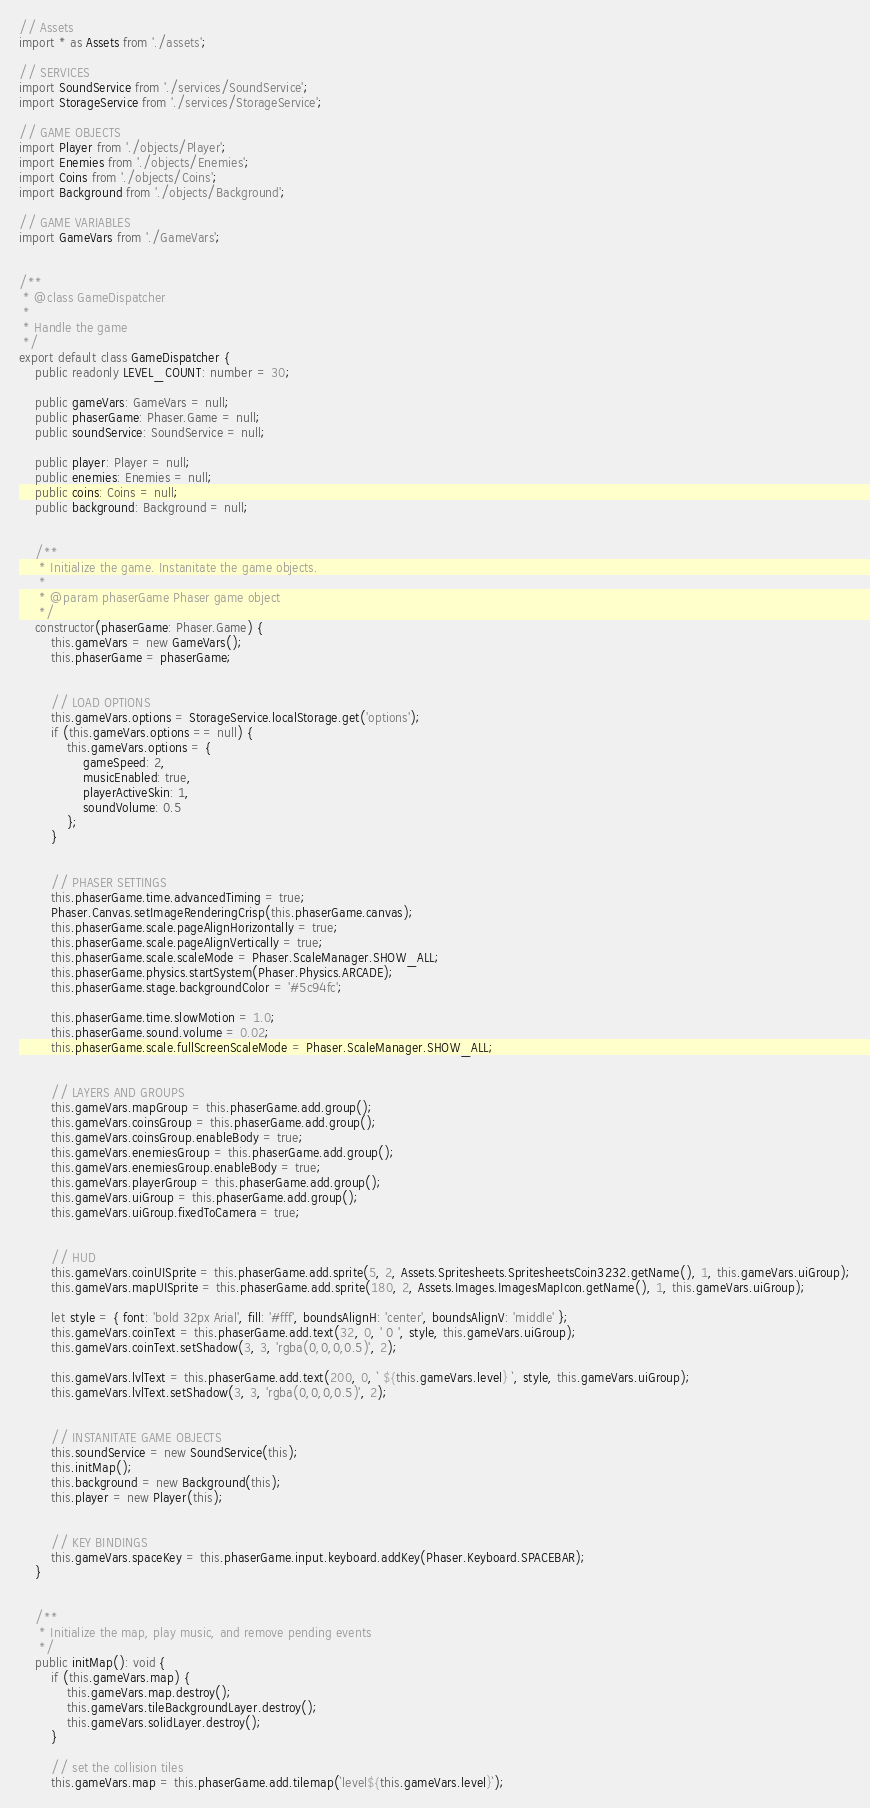Convert code to text. <code><loc_0><loc_0><loc_500><loc_500><_TypeScript_>// Assets
import * as Assets from './assets';

// SERVICES
import SoundService from './services/SoundService';
import StorageService from './services/StorageService';

// GAME OBJECTS
import Player from './objects/Player';
import Enemies from './objects/Enemies';
import Coins from './objects/Coins';
import Background from './objects/Background';

// GAME VARIABLES
import GameVars from './GameVars';


/**
 * @class GameDispatcher
 *
 * Handle the game
 */
export default class GameDispatcher {
    public readonly LEVEL_COUNT: number = 30;

    public gameVars: GameVars = null;
    public phaserGame: Phaser.Game = null;
    public soundService: SoundService = null;

    public player: Player = null;
    public enemies: Enemies = null;
    public coins: Coins = null;
    public background: Background = null;


    /**
     * Initialize the game. Instanitate the game objects.
     *
     * @param phaserGame Phaser game object
     */
    constructor(phaserGame: Phaser.Game) {
        this.gameVars = new GameVars();
        this.phaserGame = phaserGame;


        // LOAD OPTIONS
        this.gameVars.options = StorageService.localStorage.get('options');
        if (this.gameVars.options == null) {
            this.gameVars.options = {
                gameSpeed: 2,
                musicEnabled: true,
                playerActiveSkin: 1,
                soundVolume: 0.5
            };
        }


        // PHASER SETTINGS
        this.phaserGame.time.advancedTiming = true;
        Phaser.Canvas.setImageRenderingCrisp(this.phaserGame.canvas);
        this.phaserGame.scale.pageAlignHorizontally = true;
        this.phaserGame.scale.pageAlignVertically = true;
        this.phaserGame.scale.scaleMode = Phaser.ScaleManager.SHOW_ALL;
        this.phaserGame.physics.startSystem(Phaser.Physics.ARCADE);
        this.phaserGame.stage.backgroundColor = '#5c94fc';

        this.phaserGame.time.slowMotion = 1.0;
        this.phaserGame.sound.volume = 0.02;
        this.phaserGame.scale.fullScreenScaleMode = Phaser.ScaleManager.SHOW_ALL;


        // LAYERS AND GROUPS
        this.gameVars.mapGroup = this.phaserGame.add.group();
        this.gameVars.coinsGroup = this.phaserGame.add.group();
        this.gameVars.coinsGroup.enableBody = true;
        this.gameVars.enemiesGroup = this.phaserGame.add.group();
        this.gameVars.enemiesGroup.enableBody = true;
        this.gameVars.playerGroup = this.phaserGame.add.group();
        this.gameVars.uiGroup = this.phaserGame.add.group();
        this.gameVars.uiGroup.fixedToCamera = true;


        // HUD
        this.gameVars.coinUISprite = this.phaserGame.add.sprite(5, 2, Assets.Spritesheets.SpritesheetsCoin3232.getName(), 1, this.gameVars.uiGroup);
        this.gameVars.mapUISprite = this.phaserGame.add.sprite(180, 2, Assets.Images.ImagesMapIcon.getName(), 1, this.gameVars.uiGroup);

        let style = { font: 'bold 32px Arial', fill: '#fff', boundsAlignH: 'center', boundsAlignV: 'middle' };
        this.gameVars.coinText = this.phaserGame.add.text(32, 0, ' 0 ', style, this.gameVars.uiGroup);
        this.gameVars.coinText.setShadow(3, 3, 'rgba(0,0,0,0.5)', 2);

        this.gameVars.lvlText = this.phaserGame.add.text(200, 0, ` ${this.gameVars.level} `, style, this.gameVars.uiGroup);
        this.gameVars.lvlText.setShadow(3, 3, 'rgba(0,0,0,0.5)', 2);


        // INSTANITATE GAME OBJECTS
        this.soundService = new SoundService(this);
        this.initMap();
        this.background = new Background(this);
        this.player = new Player(this);


        // KEY BINDINGS
        this.gameVars.spaceKey = this.phaserGame.input.keyboard.addKey(Phaser.Keyboard.SPACEBAR);
    }


    /**
     * Initialize the map, play music, and remove pending events
     */
    public initMap(): void {
        if (this.gameVars.map) {
            this.gameVars.map.destroy();
            this.gameVars.tileBackgroundLayer.destroy();
            this.gameVars.solidLayer.destroy();
        }

        // set the collision tiles
        this.gameVars.map = this.phaserGame.add.tilemap(`level${this.gameVars.level}`);</code> 